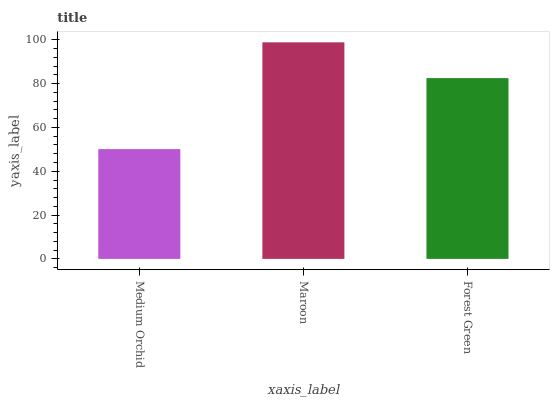Is Medium Orchid the minimum?
Answer yes or no. Yes. Is Maroon the maximum?
Answer yes or no. Yes. Is Forest Green the minimum?
Answer yes or no. No. Is Forest Green the maximum?
Answer yes or no. No. Is Maroon greater than Forest Green?
Answer yes or no. Yes. Is Forest Green less than Maroon?
Answer yes or no. Yes. Is Forest Green greater than Maroon?
Answer yes or no. No. Is Maroon less than Forest Green?
Answer yes or no. No. Is Forest Green the high median?
Answer yes or no. Yes. Is Forest Green the low median?
Answer yes or no. Yes. Is Maroon the high median?
Answer yes or no. No. Is Maroon the low median?
Answer yes or no. No. 